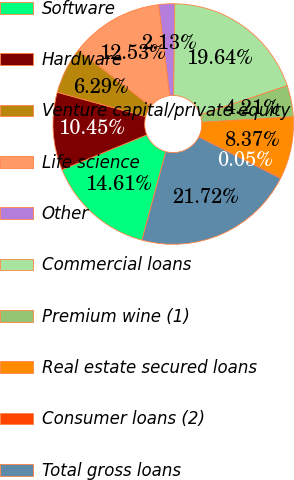<chart> <loc_0><loc_0><loc_500><loc_500><pie_chart><fcel>Software<fcel>Hardware<fcel>Venture capital/private equity<fcel>Life science<fcel>Other<fcel>Commercial loans<fcel>Premium wine (1)<fcel>Real estate secured loans<fcel>Consumer loans (2)<fcel>Total gross loans<nl><fcel>14.61%<fcel>10.45%<fcel>6.29%<fcel>12.53%<fcel>2.13%<fcel>19.64%<fcel>4.21%<fcel>8.37%<fcel>0.05%<fcel>21.72%<nl></chart> 